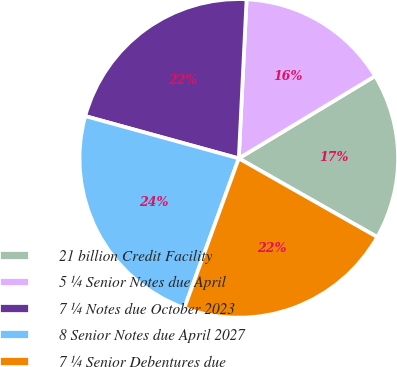Convert chart to OTSL. <chart><loc_0><loc_0><loc_500><loc_500><pie_chart><fcel>21 billion Credit Facility<fcel>5 ¼ Senior Notes due April<fcel>7 ¼ Notes due October 2023<fcel>8 Senior Notes due April 2027<fcel>7 ¼ Senior Debentures due<nl><fcel>16.87%<fcel>15.57%<fcel>21.5%<fcel>23.72%<fcel>22.33%<nl></chart> 